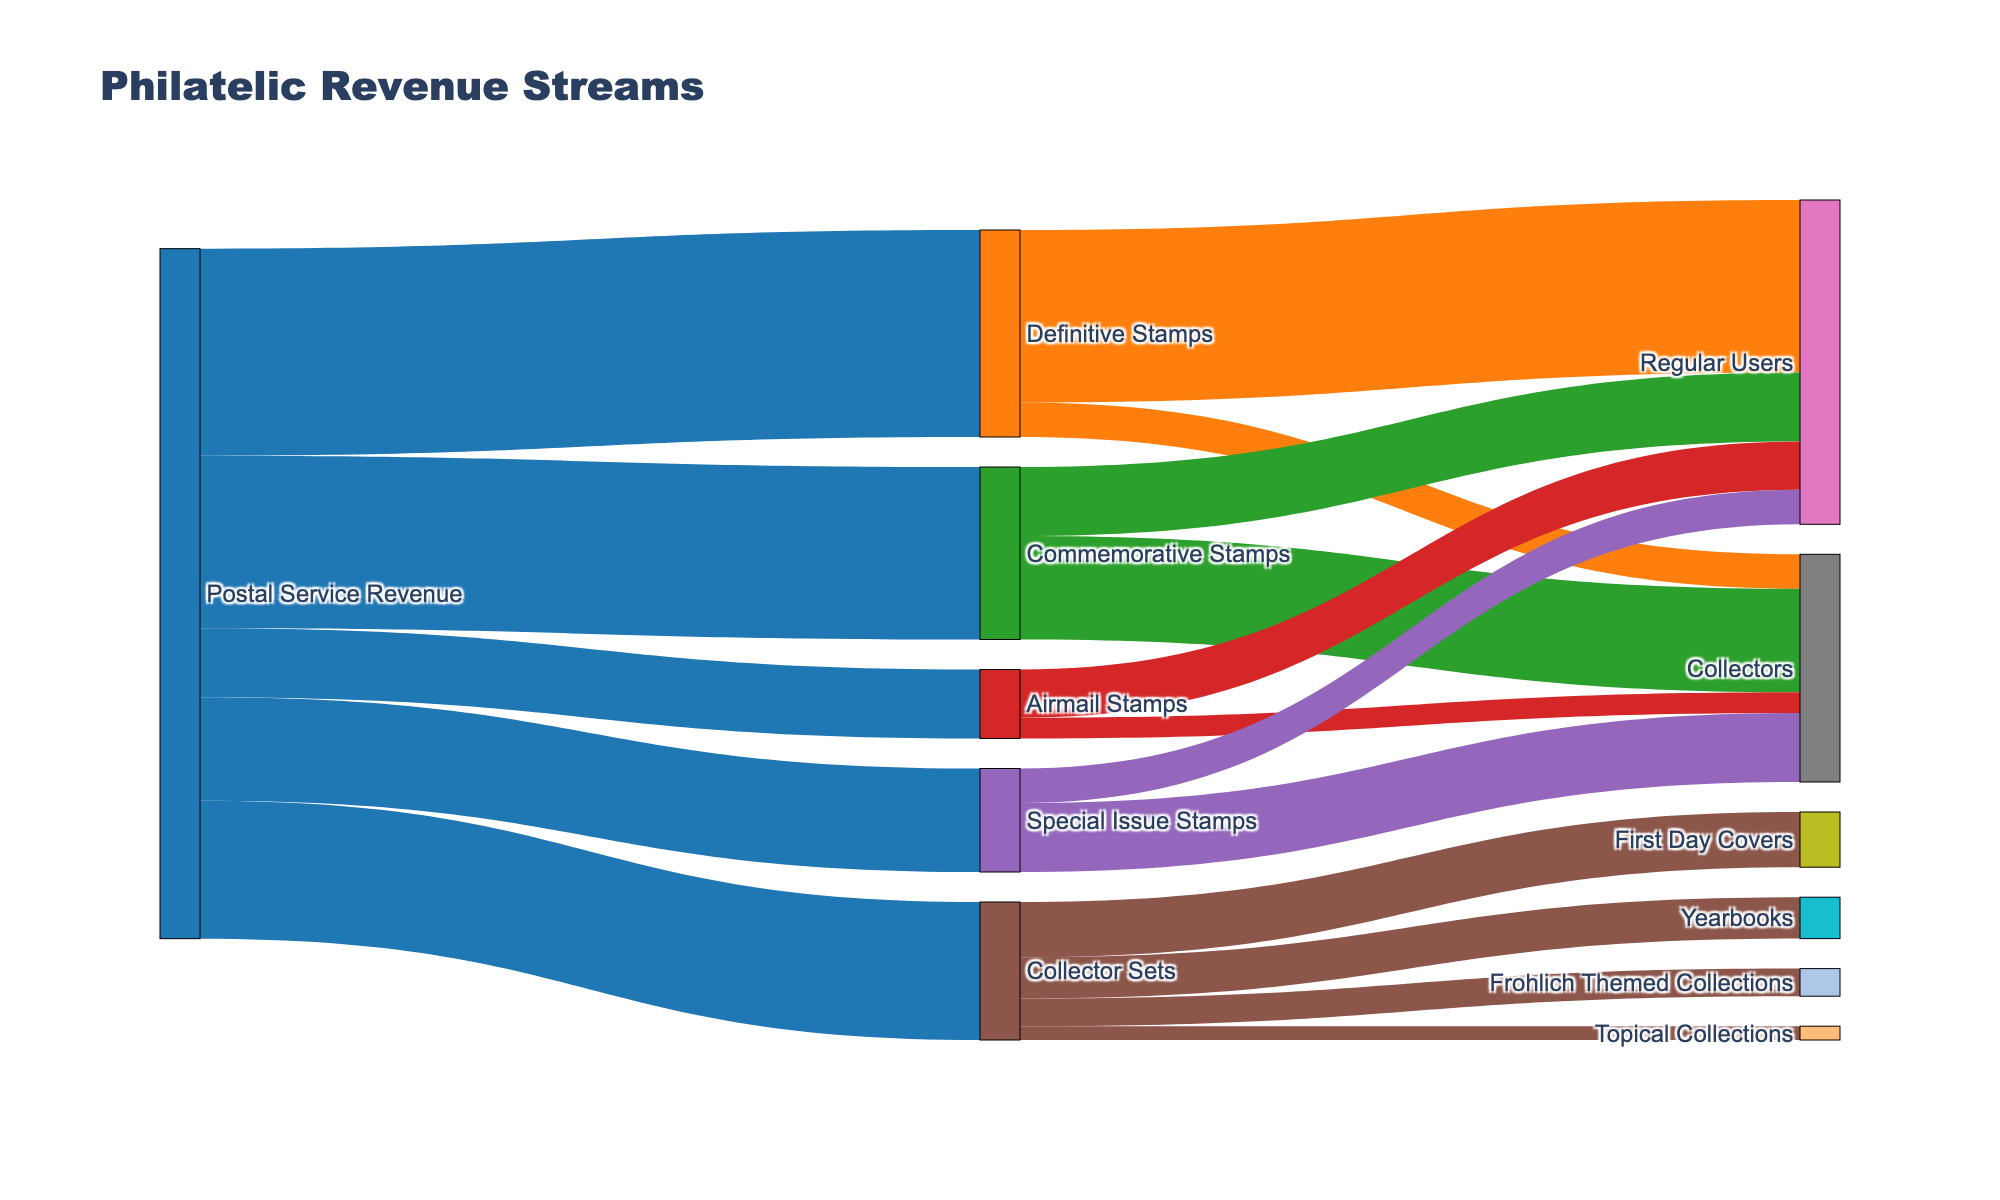What is the title of the figure? The title is prominently displayed at the top of the figure. It gives an overall description of what the Sankey Diagram represents.
Answer: Philatelic Revenue Streams What stamp type contributes the most to the Postal Service Revenue? By following the width of the flow from the "Postal Service Revenue" node to the respective stamp types, the width for "Definitive Stamps" is the largest.
Answer: Definitive Stamps Which collector-oriented product from "Collector Sets" has the highest value? The "Collector Sets" node has outgoing flows to various products. The widest flow is towards "First Day Covers."
Answer: First Day Covers How much total revenue comes from stamps used by regular users? Add up the values of revenue directed to "Regular Users" from different stamp types: 25 (Definitive) + 10 (Commemorative) + 7 (Airmail) + 5 (Special Issue).
Answer: 47 Compare the revenue from Commemorative Stamps used by Regular Users and Collectors. Which is higher? Check the flows from "Commemorative Stamps" to both "Regular Users" and "Collectors." The flow to "Collectors" is wider.
Answer: Collectors What is the total revenue generated from Collectors? Sum the values flowing into "Collectors" from various stamp types: 5 (Definitive) + 15 (Commemorative) + 3 (Airmail) + 10 (Special Issue).
Answer: 33 Which specific flow from "Collector Sets" is associated with Alfredo Frohlich? The flow from "Collector Sets" to "Frohlich Themed Collections" is labeled directly.
Answer: Frohlich Themed Collections What percentage of the total Postal Service Revenue comes from Special Issue Stamps? Calculate the percentage by dividing the revenue from "Special Issue Stamps" by the total Postal Service Revenue: (15 / (30 + 25 + 10 + 15 + 20)) * 100.
Answer: 15% Compare the values between Definitive Stamps used by Regular Users and Commemorative Stamps used by Collectors. Which is higher and by how much? Subtract the values of Definitive Stamps used by Regular Users (25) and Commemorative Stamps used by Collectors (15): 25 - 15 = 10. Definitive Stamps used by Regular Users is higher by 10.
Answer: Definitive Stamps by 10 What is the combined revenue from "Yearbooks" and "Topical Collections"? Sum the revenue flowing from "Collector Sets" to "Yearbooks" (6) and "Topical Collections" (2).
Answer: 8 